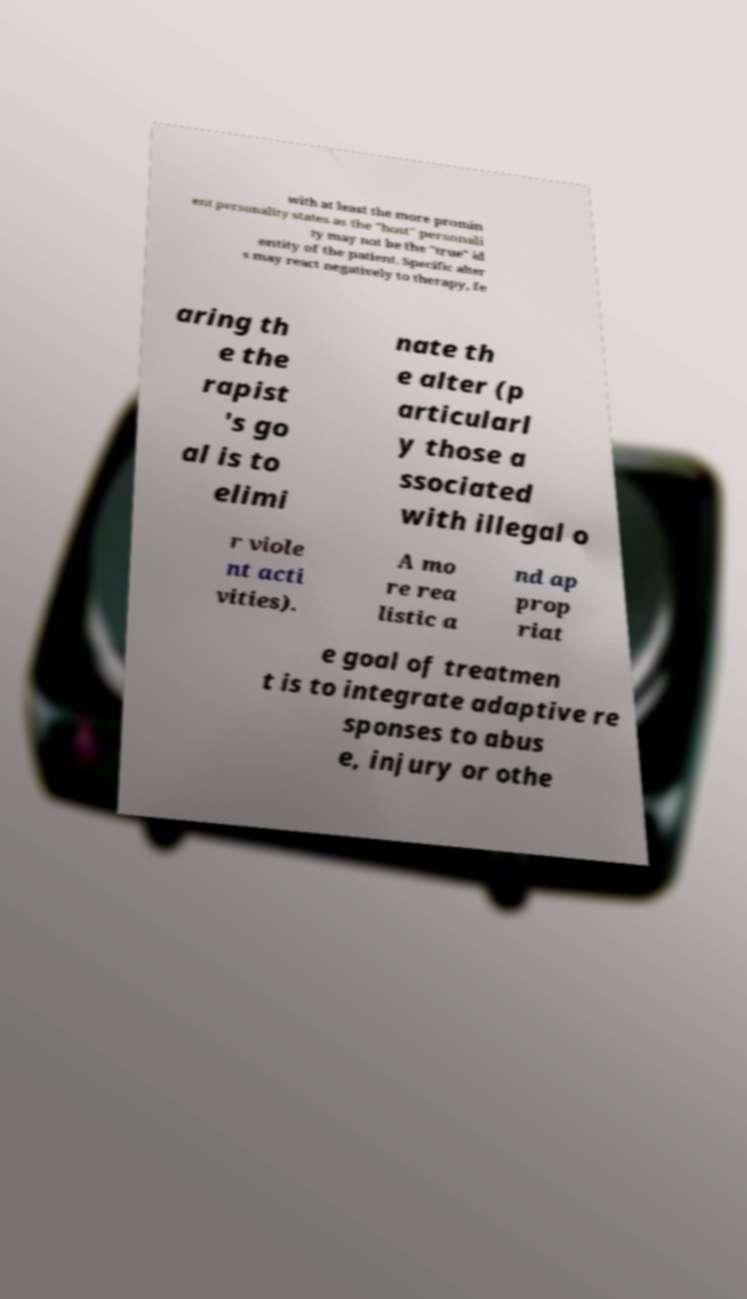Please identify and transcribe the text found in this image. with at least the more promin ent personality states as the "host" personali ty may not be the "true" id entity of the patient. Specific alter s may react negatively to therapy, fe aring th e the rapist 's go al is to elimi nate th e alter (p articularl y those a ssociated with illegal o r viole nt acti vities). A mo re rea listic a nd ap prop riat e goal of treatmen t is to integrate adaptive re sponses to abus e, injury or othe 